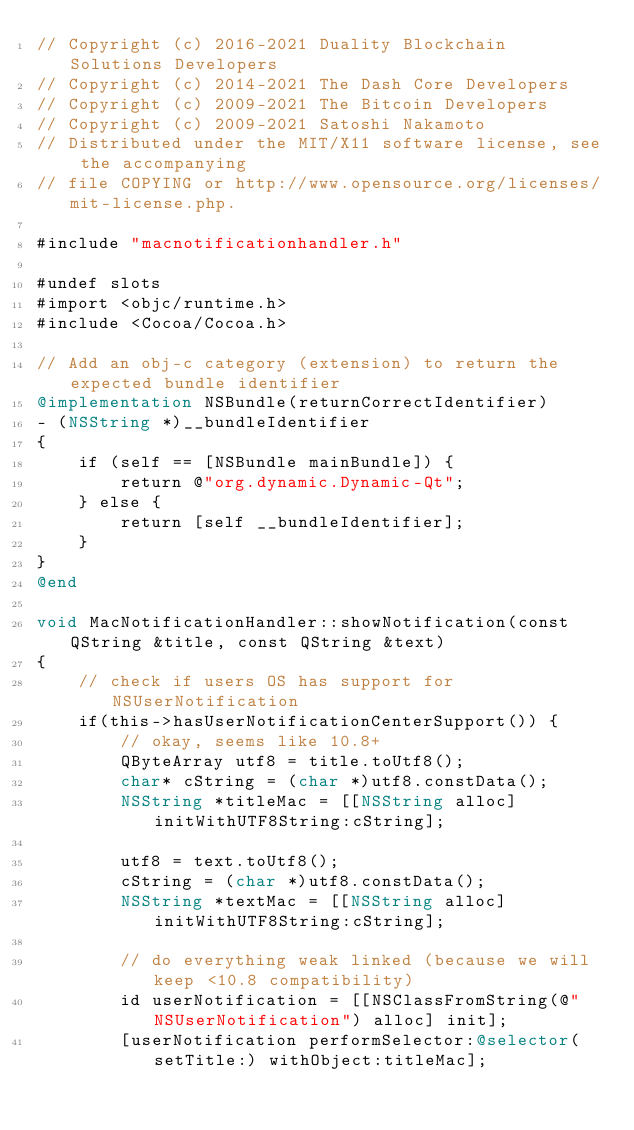<code> <loc_0><loc_0><loc_500><loc_500><_ObjectiveC_>// Copyright (c) 2016-2021 Duality Blockchain Solutions Developers
// Copyright (c) 2014-2021 The Dash Core Developers
// Copyright (c) 2009-2021 The Bitcoin Developers
// Copyright (c) 2009-2021 Satoshi Nakamoto
// Distributed under the MIT/X11 software license, see the accompanying
// file COPYING or http://www.opensource.org/licenses/mit-license.php.

#include "macnotificationhandler.h"

#undef slots
#import <objc/runtime.h>
#include <Cocoa/Cocoa.h>

// Add an obj-c category (extension) to return the expected bundle identifier
@implementation NSBundle(returnCorrectIdentifier)
- (NSString *)__bundleIdentifier
{
    if (self == [NSBundle mainBundle]) {
        return @"org.dynamic.Dynamic-Qt";
    } else {
        return [self __bundleIdentifier];
    }
}
@end

void MacNotificationHandler::showNotification(const QString &title, const QString &text)
{
    // check if users OS has support for NSUserNotification
    if(this->hasUserNotificationCenterSupport()) {
        // okay, seems like 10.8+
        QByteArray utf8 = title.toUtf8();
        char* cString = (char *)utf8.constData();
        NSString *titleMac = [[NSString alloc] initWithUTF8String:cString];

        utf8 = text.toUtf8();
        cString = (char *)utf8.constData();
        NSString *textMac = [[NSString alloc] initWithUTF8String:cString];

        // do everything weak linked (because we will keep <10.8 compatibility)
        id userNotification = [[NSClassFromString(@"NSUserNotification") alloc] init];
        [userNotification performSelector:@selector(setTitle:) withObject:titleMac];</code> 